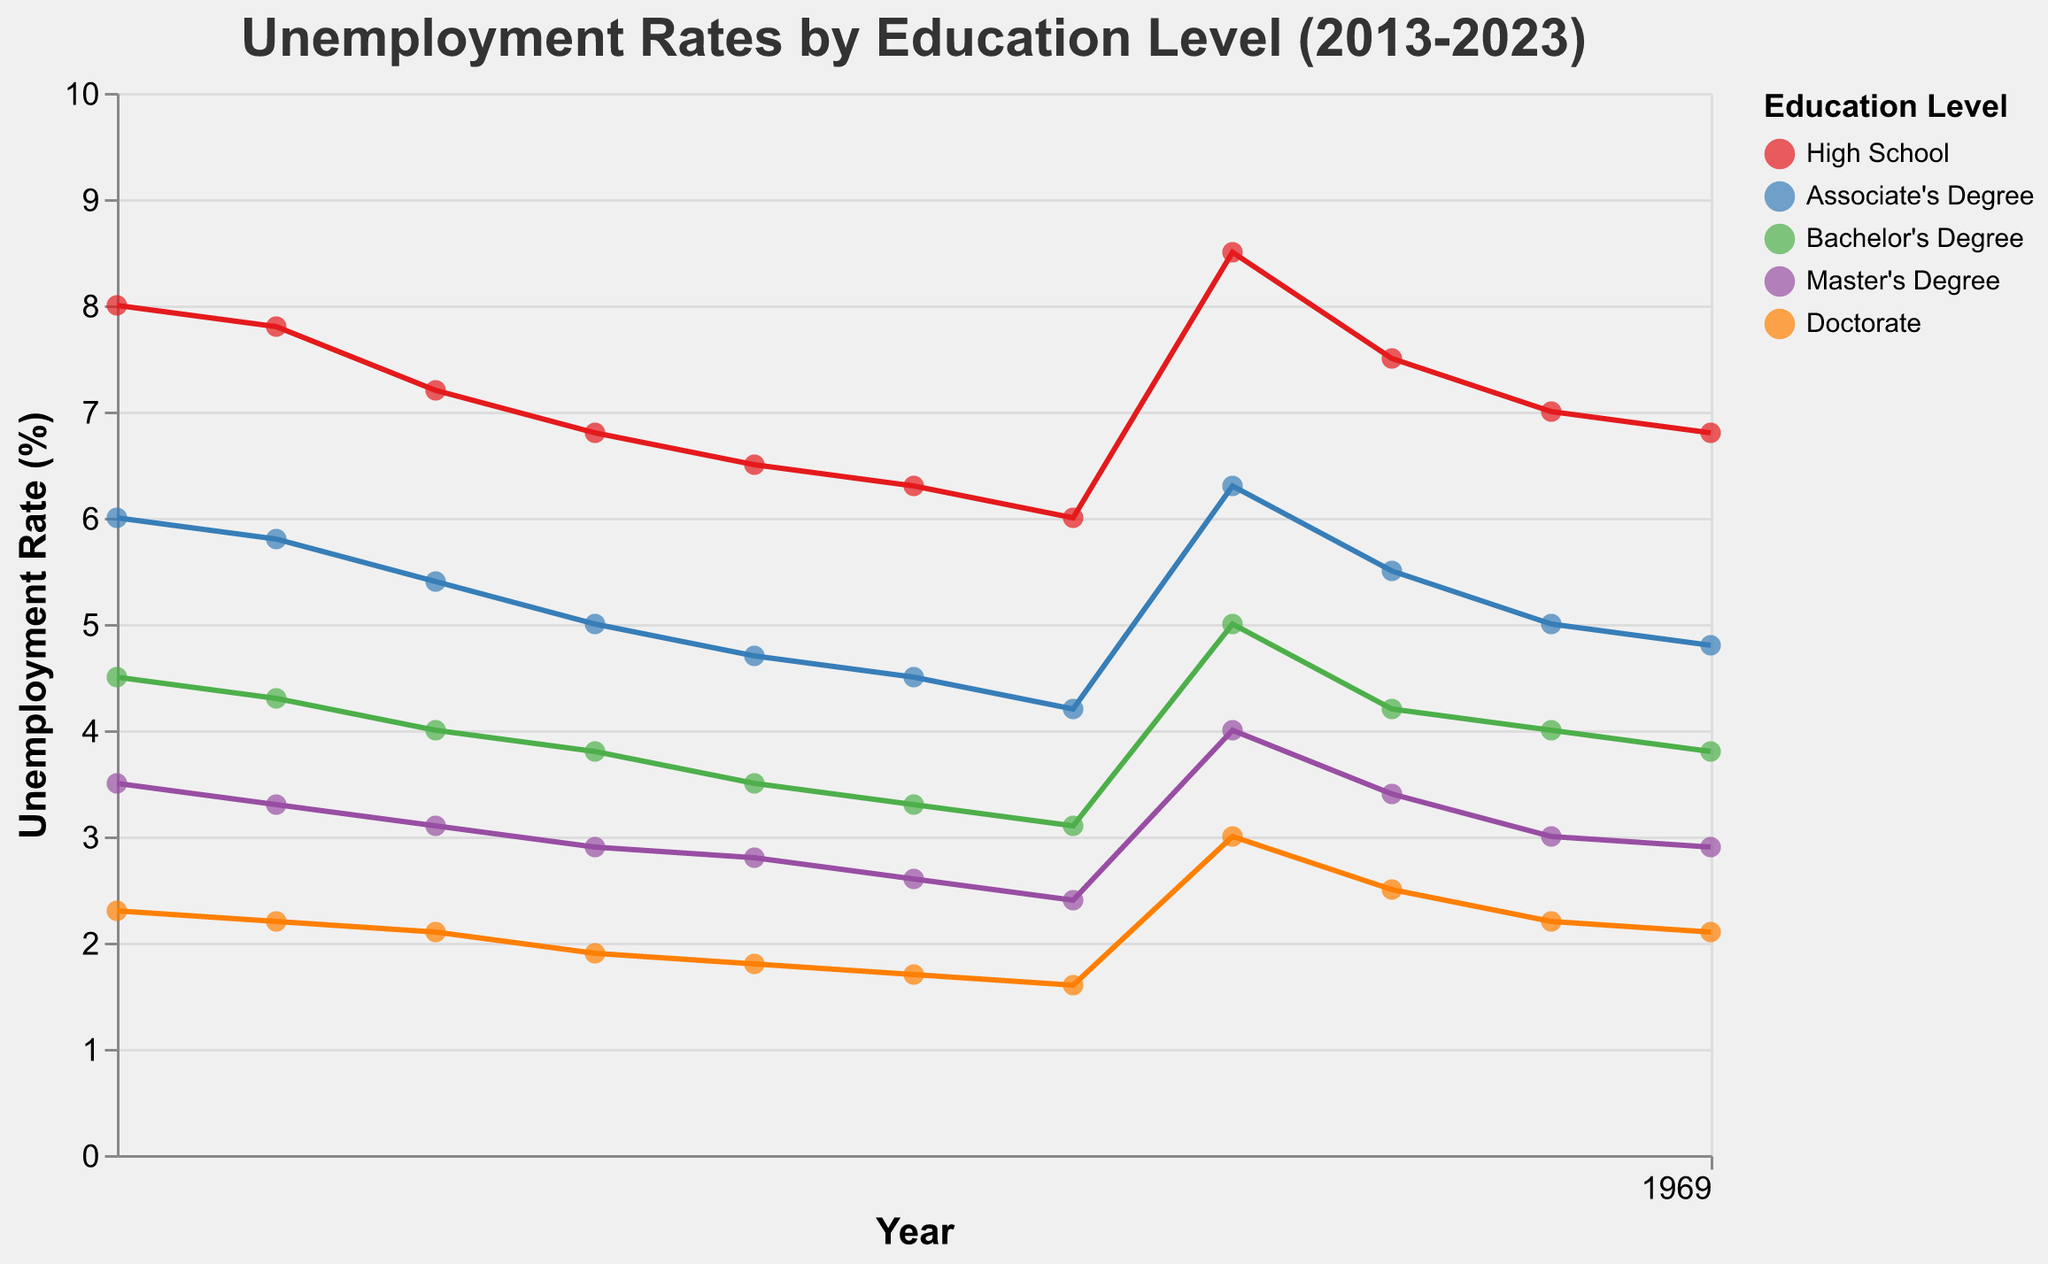What is the title of the figure? The title is usually placed at the top of the figure and describes its overall theme, summarizing the plot’s subject.
Answer: Unemployment Rates by Education Level (2013-2023) Which education level had the highest unemployment rate in 2020? Look for the year 2020 on the x-axis and identify the highest point among that year's data points. The color legend helps to match the data point to the education level.
Answer: High School How did the unemployment rate for Bachelor's Degree holders change from 2013 to 2017? Identify the data points for Bachelor's Degree for the years 2013 and 2017. Compare the unemployment rates for these two data points.
Answer: Decreased from 4.5% to 3.5% What is the average unemployment rate for Doctorate holders over the entire period? Extract the unemployment rates for Doctorate holders from 2013 to 2023. Calculate their average. Unemployment rates: 2.3, 2.2, 2.1, 1.9, 1.8, 1.7, 1.6, 3.0, 2.5, 2.2, 2.1. Sum these values and divide by the number of values (11).
Answer: 2.02% Which year had the lowest unemployment rate for High School education? Identify the data points for High School for all years. Find the minimum unemployment rate among these points.
Answer: 2019 Compare the unemployment rate trends for Master's Degree and Associate's Degree. Which one had a steeper decrease over the period? Examine the trend lines for both Master's Degree and Associate's Degree. Calculate the change in unemployment rates from 2013 to 2023 for both. Master's Degree: 3.5% to 2.9% (0.6% decrease). Associate's Degree: 6.0% to 4.8% (1.2% decrease).
Answer: Associate's Degree What was the impact of the year 2020 on the unemployment rates for all education levels? Look at the data points for the year 2020 and compare them with the previous and following years to determine the change and impact. The 2020 points are significantly higher for all education levels compared to both 2019 and 2021, indicating a substantial rise.
Answer: Significant increase Which education level consistently had the lowest unemployment rate each year? Observe the data points for each education level year by year. Determine which education level has the lowest points most frequently.
Answer: Doctorate How many data points are there in the figure? Count the total number of data points plotted on the figure. There are data points for five education levels over 11 years (2013-2023), resulting in 5 x 11.
Answer: 55 Calculate the difference in unemployment rates between Bachelor's Degree and High School in 2023. Identify the data points for Bachelor's Degree and High School in 2023. Subtract the unemployment rate of Bachelor's Degree from High School. Bachelor's Degree: 3.8%, High School: 6.8%, so 6.8% - 3.8%.
Answer: 3.0% 